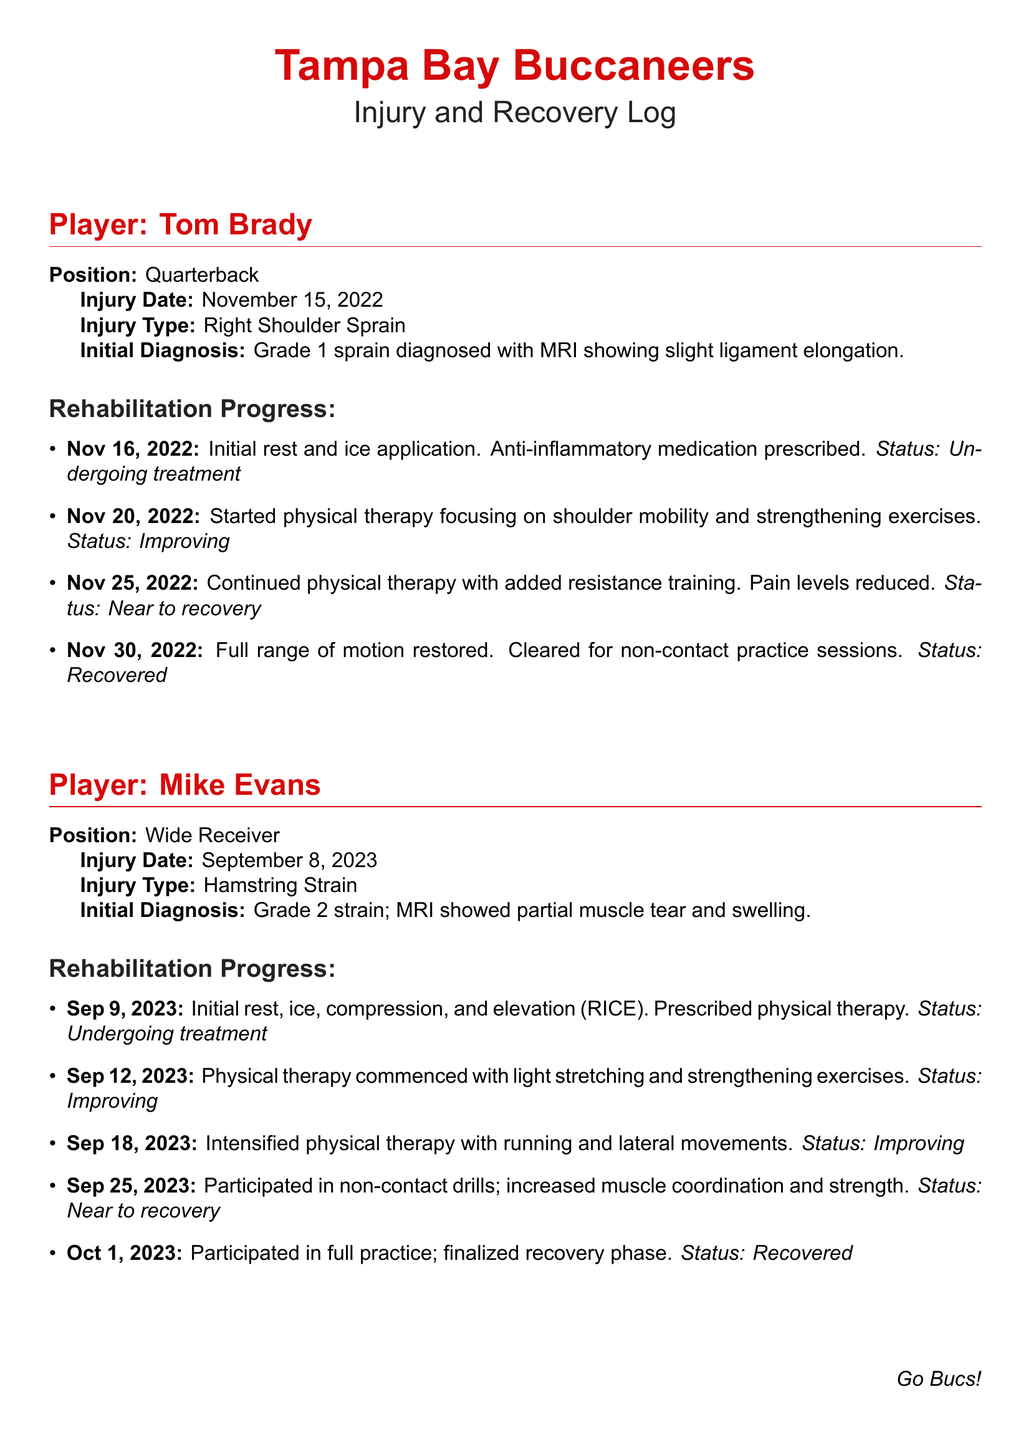What is Tom Brady's injury type? The injury type listed for Tom Brady is a right shoulder sprain.
Answer: Right Shoulder Sprain When did Mike Evans sustain his injury? The document states that Mike Evans sustained his injury on September 8, 2023.
Answer: September 8, 2023 What was the initial diagnosis for Tom Brady's injury? The initial diagnosis for Tom Brady's injury was a grade 1 sprain diagnosed with an MRI showing slight ligament elongation.
Answer: Grade 1 sprain diagnosed with MRI showing slight ligament elongation What date did Tom Brady begin physical therapy? According to the document, Tom Brady began physical therapy on November 20, 2022.
Answer: November 20, 2022 What is Mike Evans's position? Mike Evans is listed as a wide receiver in the document.
Answer: Wide Receiver How many days after the injury did Mike Evans participate in full practice? Mike Evans participated in full practice 23 days after his injury on September 8, 2023.
Answer: 23 days What treatment method was first prescribed to Mike Evans? The first treatment method prescribed to Mike Evans was the RICE method (rest, ice, compression, and elevation).
Answer: RICE What was the status of Tom Brady on November 30, 2022? On November 30, 2022, Tom Brady was cleared for non-contact practice sessions, indicating he was recovered.
Answer: Recovered Which player had a hamstring strain? The player who had a hamstring strain is Mike Evans.
Answer: Mike Evans 